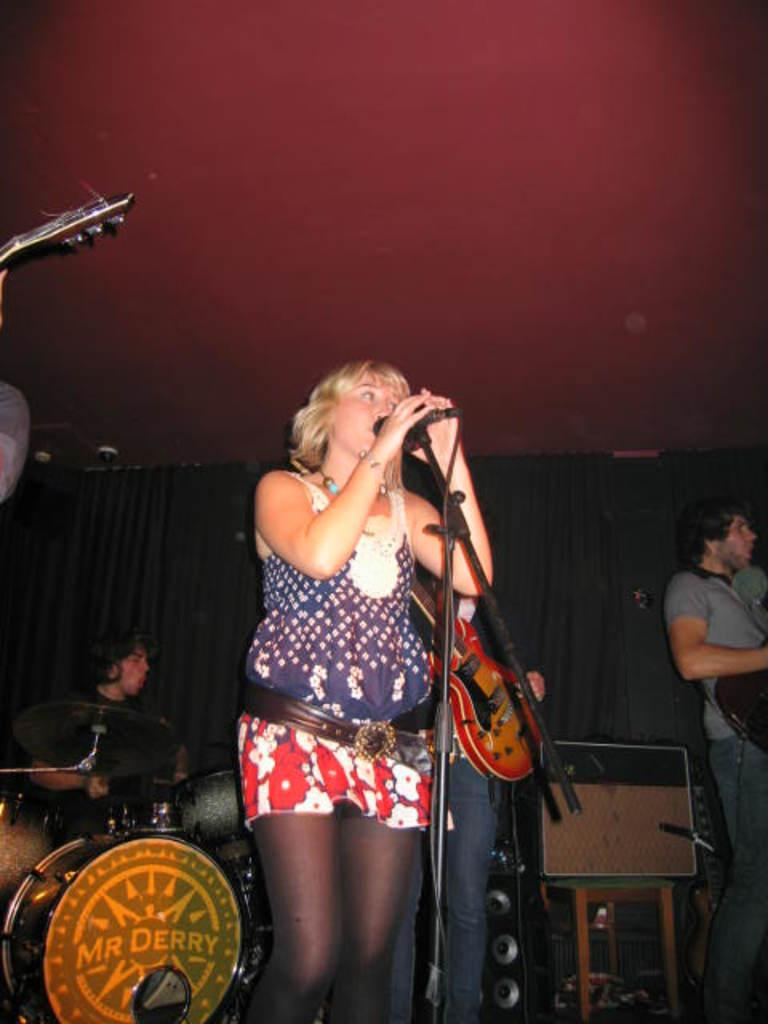How many people are present in the image? There are four people in the image. What is one person doing in the image? One person is standing in front of a mic. What instrument is being played by a person in the image? There is a person playing the drum set in the image. What type of tray is being used by the person in the image? There is no tray present in the image. How does the person in the bath contribute to the music in the image? There is no person in a bath in the image, and therefore no such contribution can be observed. 